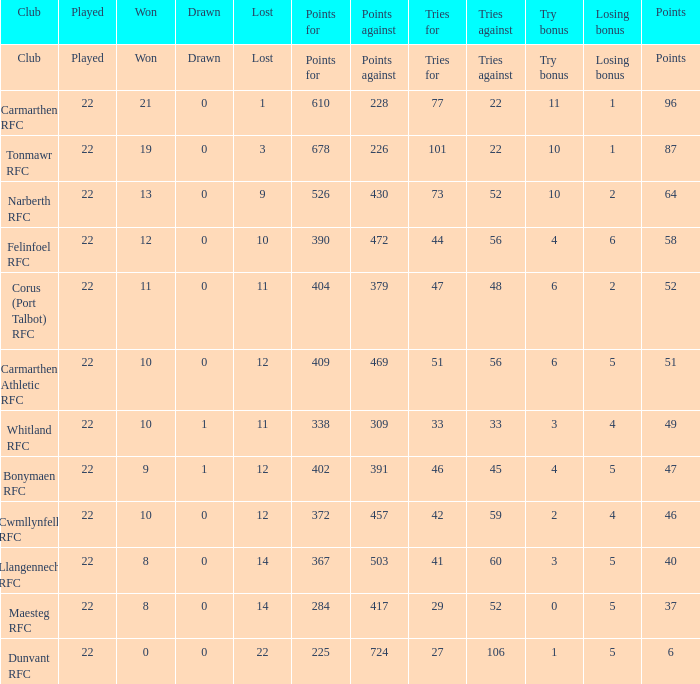Identify the attempts made to achieve 87 points. 22.0. 